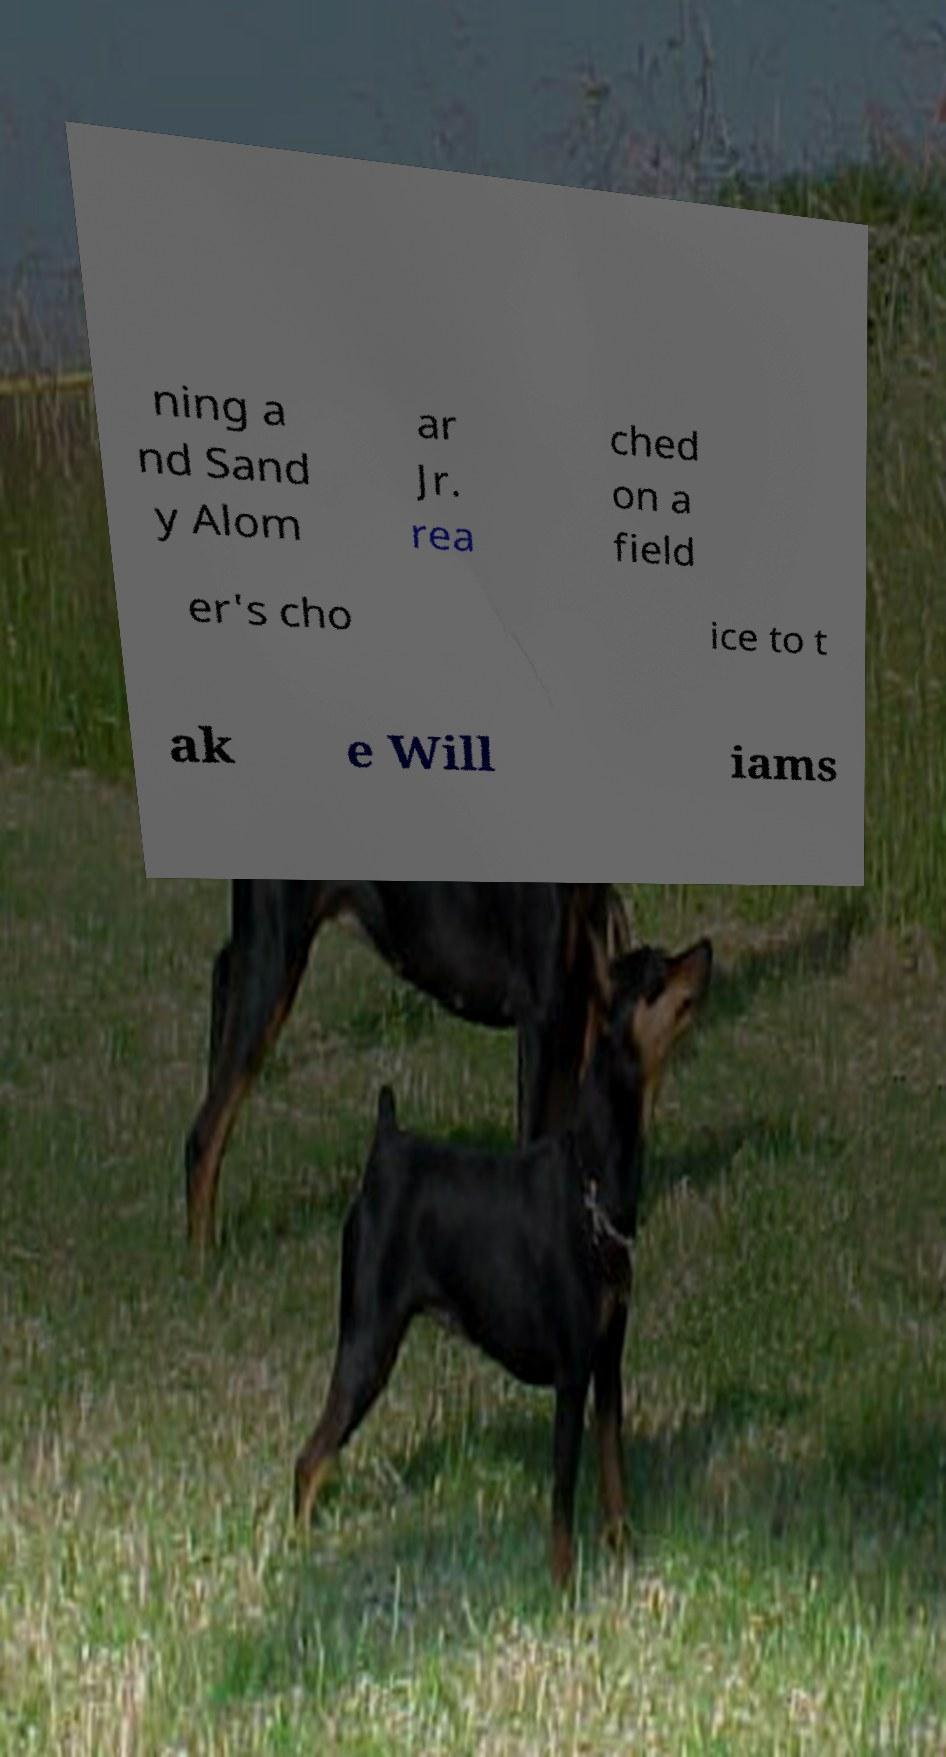Can you accurately transcribe the text from the provided image for me? ning a nd Sand y Alom ar Jr. rea ched on a field er's cho ice to t ak e Will iams 